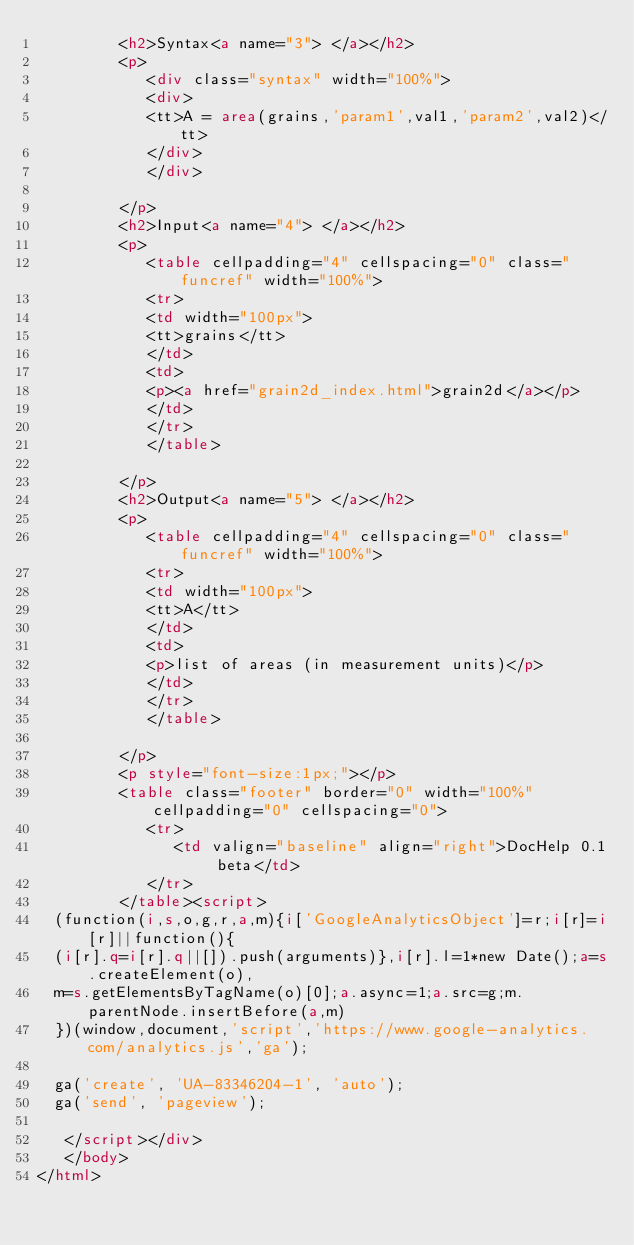Convert code to text. <code><loc_0><loc_0><loc_500><loc_500><_HTML_>         <h2>Syntax<a name="3"> </a></h2>
         <p>
            <div class="syntax" width="100%">
            <div>
            <tt>A = area(grains,'param1',val1,'param2',val2)</tt>
            </div>
            </div>
            
         </p>
         <h2>Input<a name="4"> </a></h2>
         <p>
            <table cellpadding="4" cellspacing="0" class="funcref" width="100%">
            <tr>
            <td width="100px">
            <tt>grains</tt>
            </td>
            <td>
            <p><a href="grain2d_index.html">grain2d</a></p>
            </td>
            </tr>
            </table>
            
         </p>
         <h2>Output<a name="5"> </a></h2>
         <p>
            <table cellpadding="4" cellspacing="0" class="funcref" width="100%">
            <tr>
            <td width="100px">
            <tt>A</tt>
            </td>
            <td>
            <p>list of areas (in measurement units)</p>
            </td>
            </tr>
            </table>
            
         </p>
         <p style="font-size:1px;"></p>
         <table class="footer" border="0" width="100%" cellpadding="0" cellspacing="0">
            <tr>
               <td valign="baseline" align="right">DocHelp 0.1 beta</td>
            </tr>
         </table><script>
  (function(i,s,o,g,r,a,m){i['GoogleAnalyticsObject']=r;i[r]=i[r]||function(){
  (i[r].q=i[r].q||[]).push(arguments)},i[r].l=1*new Date();a=s.createElement(o),
  m=s.getElementsByTagName(o)[0];a.async=1;a.src=g;m.parentNode.insertBefore(a,m)
  })(window,document,'script','https://www.google-analytics.com/analytics.js','ga');

  ga('create', 'UA-83346204-1', 'auto');
  ga('send', 'pageview');

   </script></div>
   </body>
</html></code> 